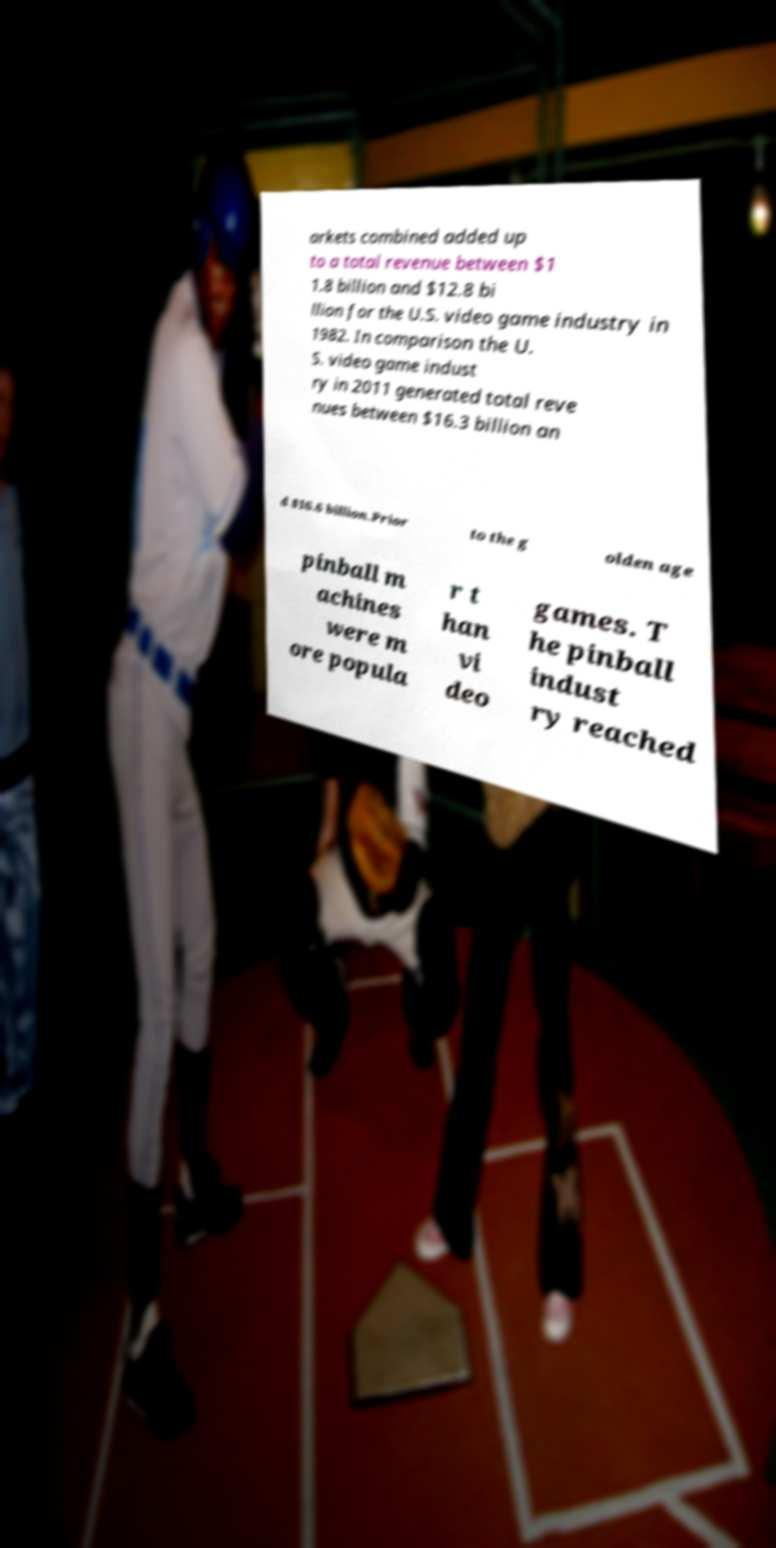Can you accurately transcribe the text from the provided image for me? arkets combined added up to a total revenue between $1 1.8 billion and $12.8 bi llion for the U.S. video game industry in 1982. In comparison the U. S. video game indust ry in 2011 generated total reve nues between $16.3 billion an d $16.6 billion.Prior to the g olden age pinball m achines were m ore popula r t han vi deo games. T he pinball indust ry reached 